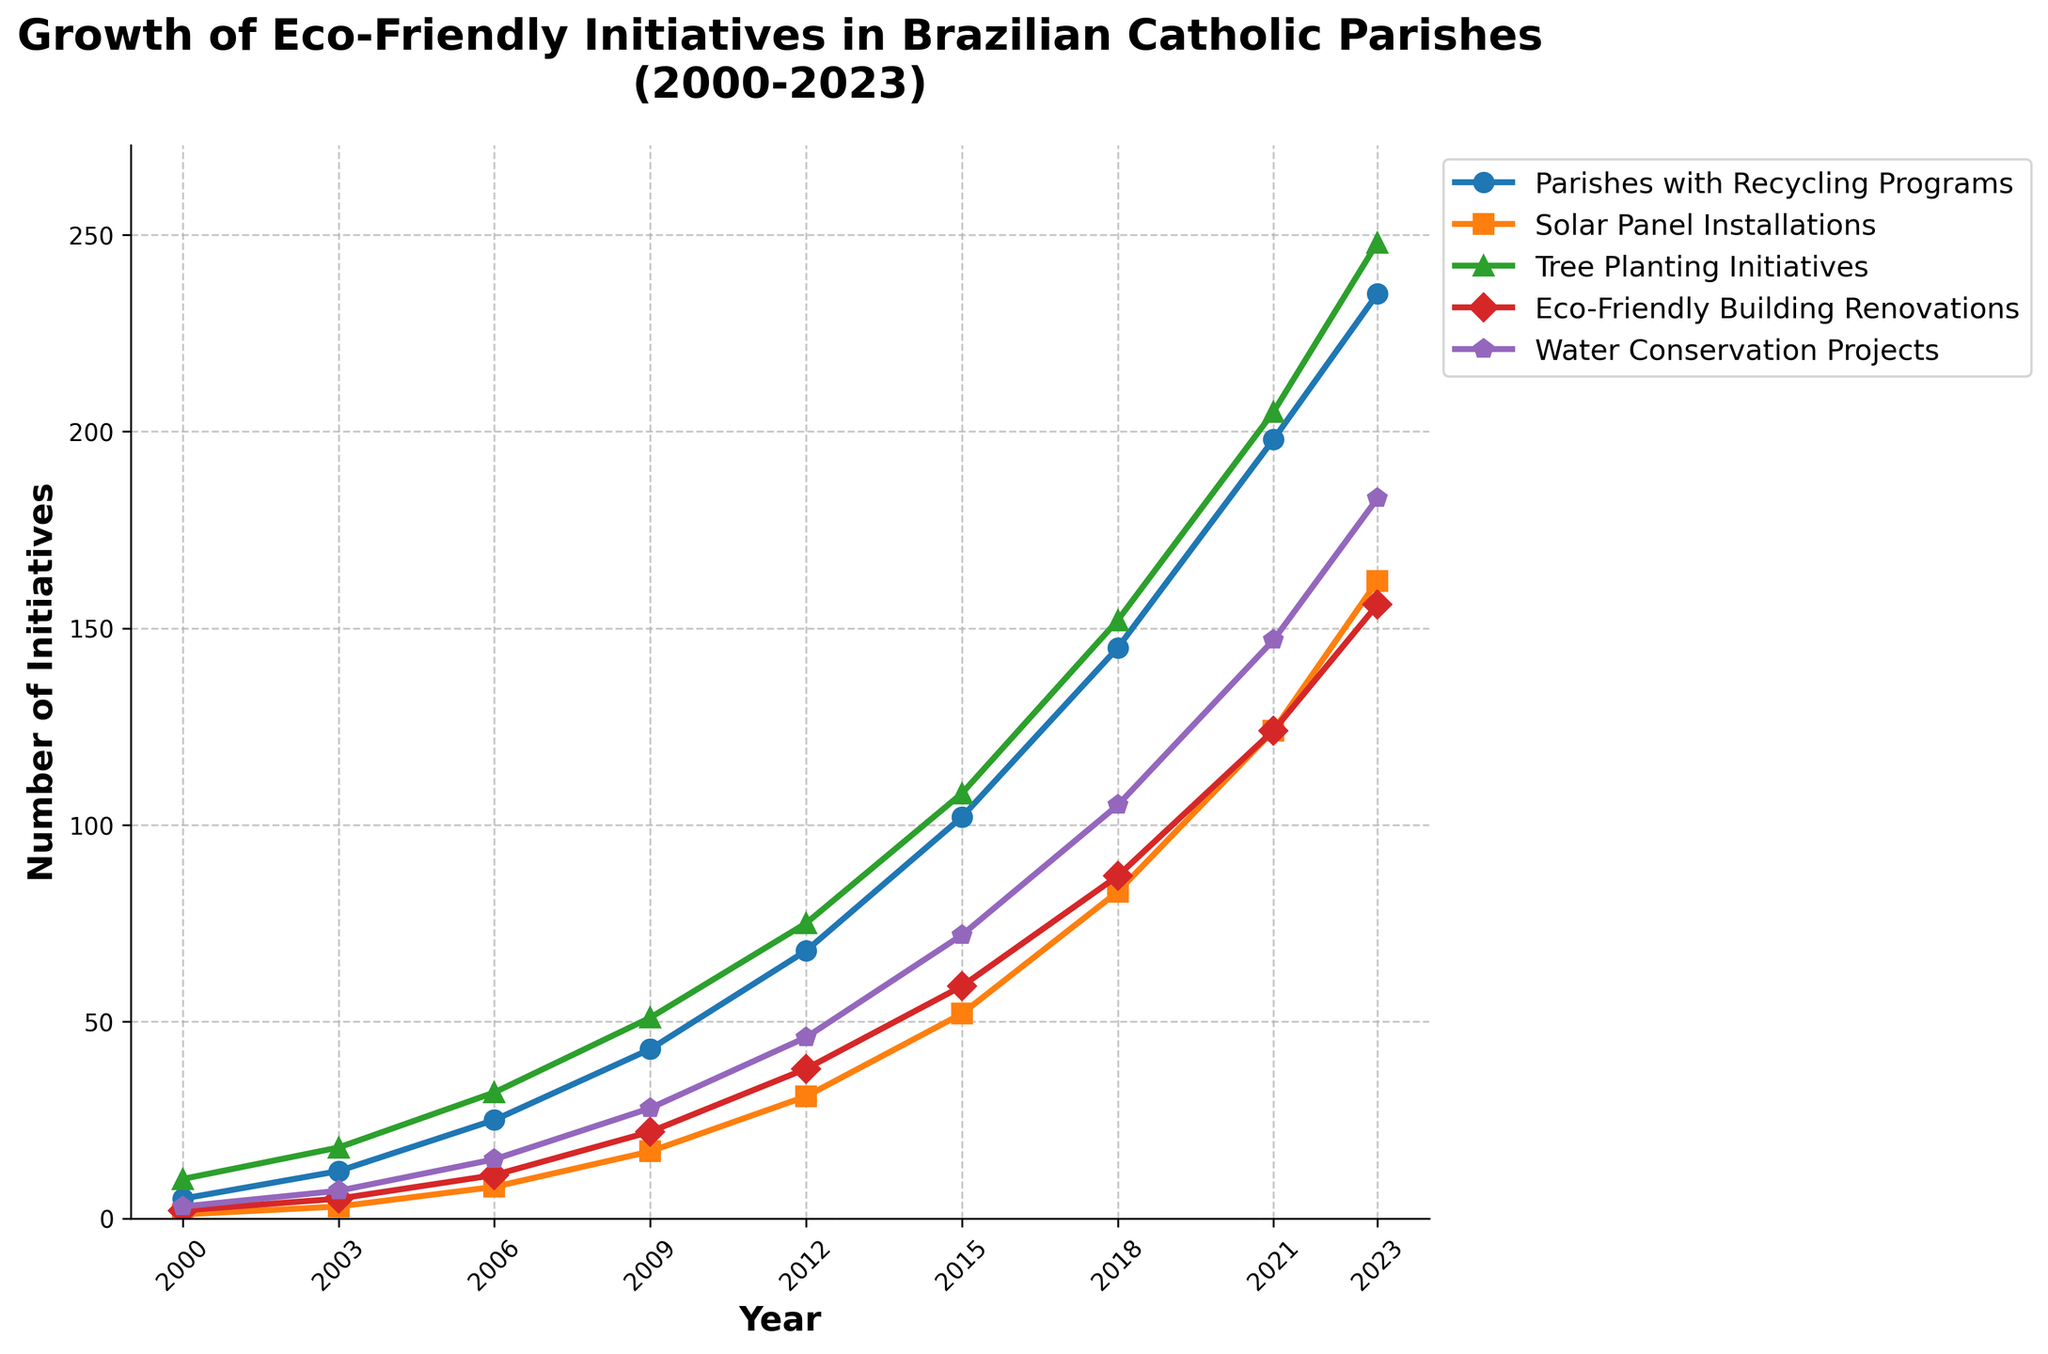When did the number of parishes with recycling programs first exceed 100? From the curve representing parishes with recycling programs, we observe that the number first surpasses 100 between 2012 and 2015. Specifically, in 2015, the number of parishes with recycling programs is 102, which exceeds 100.
Answer: 2015 Which initiative had the highest growth rate between 2018 and 2021? By comparing the slopes of the growth curves from 2018 to 2021, the water conservation projects curve has the steepest slope, indicating the highest growth rate among the initiatives.
Answer: Water Conservation Projects How many total initiatives were there across all categories in 2023? To find the total number of initiatives in 2023, sum the values for each category: 235 (Recycling Programs) + 162 (Solar Panel Installations) + 248 (Tree Planting Initiatives) + 156 (Eco-Friendly Building Renovations) + 183 (Water Conservation Projects).
Answer: 984 By how much did the parishes with solar panel installations increase from 2009 to 2012? In 2009, the number of solar panel installations was 17. In 2012, it increased to 31. The difference between these values is 31 - 17 = 14.
Answer: 14 Which initiative had the slowest growth from 2000 to 2023? From the plot, the curve representing solar panel installations grows slower compared to others over the entire period from 2000 to 2023.
Answer: Solar Panel Installations In which year did the number of eco-friendly building renovations triple compared to the year 2000? In 2000, there were 2 eco-friendly building renovations. To find the year where this number tripled (2 * 3 = 6), look at the curve's progression. In 2003, it surpasses 6 with a value of 5.
Answer: 2003 What is the difference in the number of water conservation projects between 2015 and 2023? The number of water conservation projects in 2015 is 72, and in 2023 it is 183. The difference is found by subtracting these values: 183 - 72 = 111.
Answer: 111 